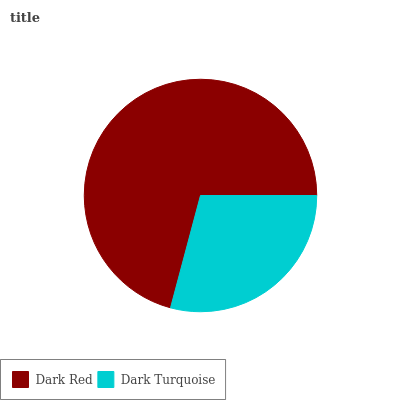Is Dark Turquoise the minimum?
Answer yes or no. Yes. Is Dark Red the maximum?
Answer yes or no. Yes. Is Dark Turquoise the maximum?
Answer yes or no. No. Is Dark Red greater than Dark Turquoise?
Answer yes or no. Yes. Is Dark Turquoise less than Dark Red?
Answer yes or no. Yes. Is Dark Turquoise greater than Dark Red?
Answer yes or no. No. Is Dark Red less than Dark Turquoise?
Answer yes or no. No. Is Dark Red the high median?
Answer yes or no. Yes. Is Dark Turquoise the low median?
Answer yes or no. Yes. Is Dark Turquoise the high median?
Answer yes or no. No. Is Dark Red the low median?
Answer yes or no. No. 